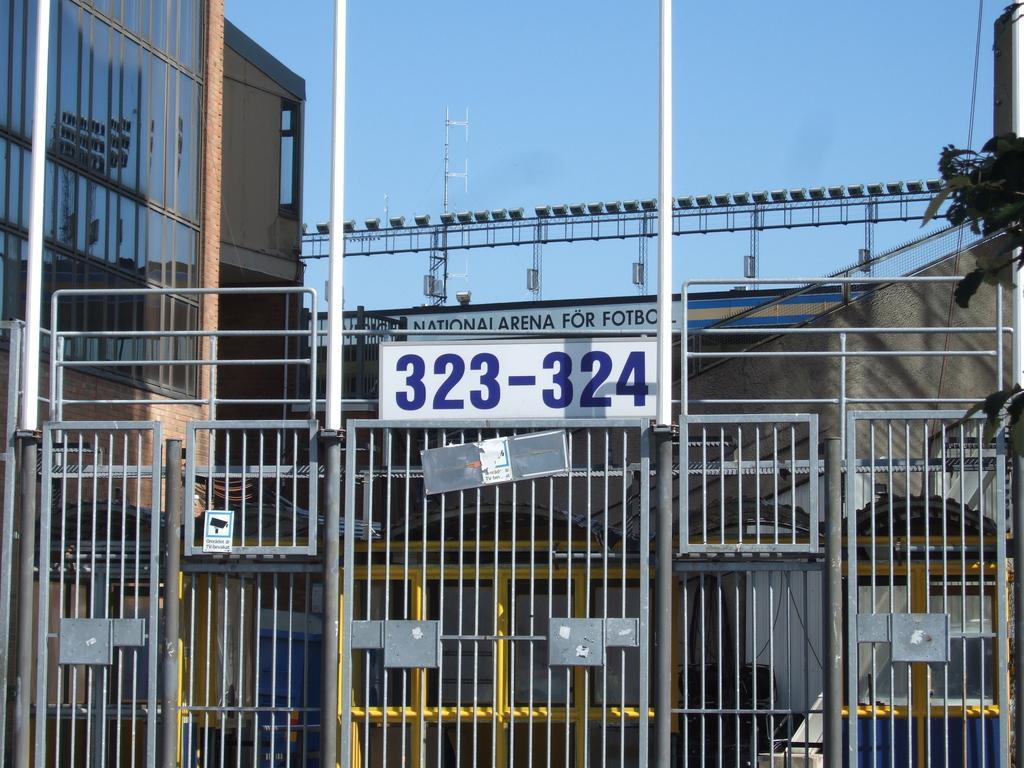Could you give a brief overview of what you see in this image? This picture is clicked outside. In the foreground we can see the text and numbers on the boards and we can see the metal rods. In the center we can see a building, metal rods and some objects seems to be the lights. On the right corner we can see an object. In the background we can see the sky and some other objects. 